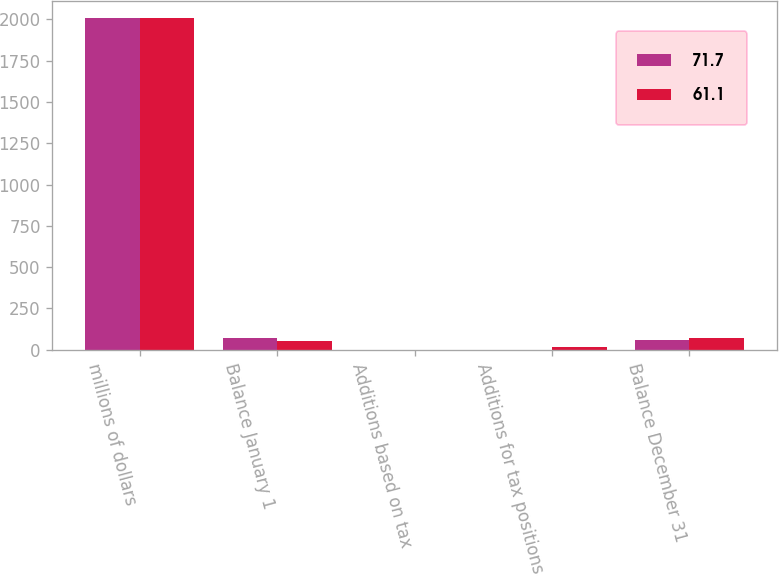Convert chart to OTSL. <chart><loc_0><loc_0><loc_500><loc_500><stacked_bar_chart><ecel><fcel>millions of dollars<fcel>Balance January 1<fcel>Additions based on tax<fcel>Additions for tax positions of<fcel>Balance December 31<nl><fcel>71.7<fcel>2008<fcel>71.7<fcel>0.5<fcel>0.2<fcel>61.1<nl><fcel>61.1<fcel>2007<fcel>50.5<fcel>1.2<fcel>20<fcel>71.7<nl></chart> 